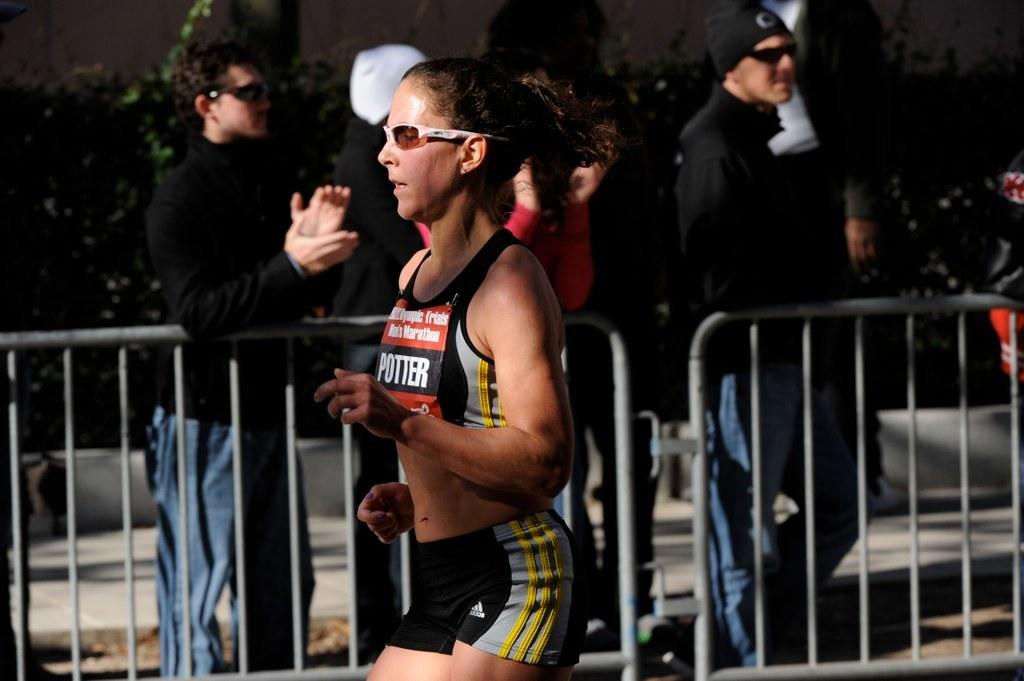<image>
Describe the image concisely. A woman with the word Potter on her chest runs in a race. 